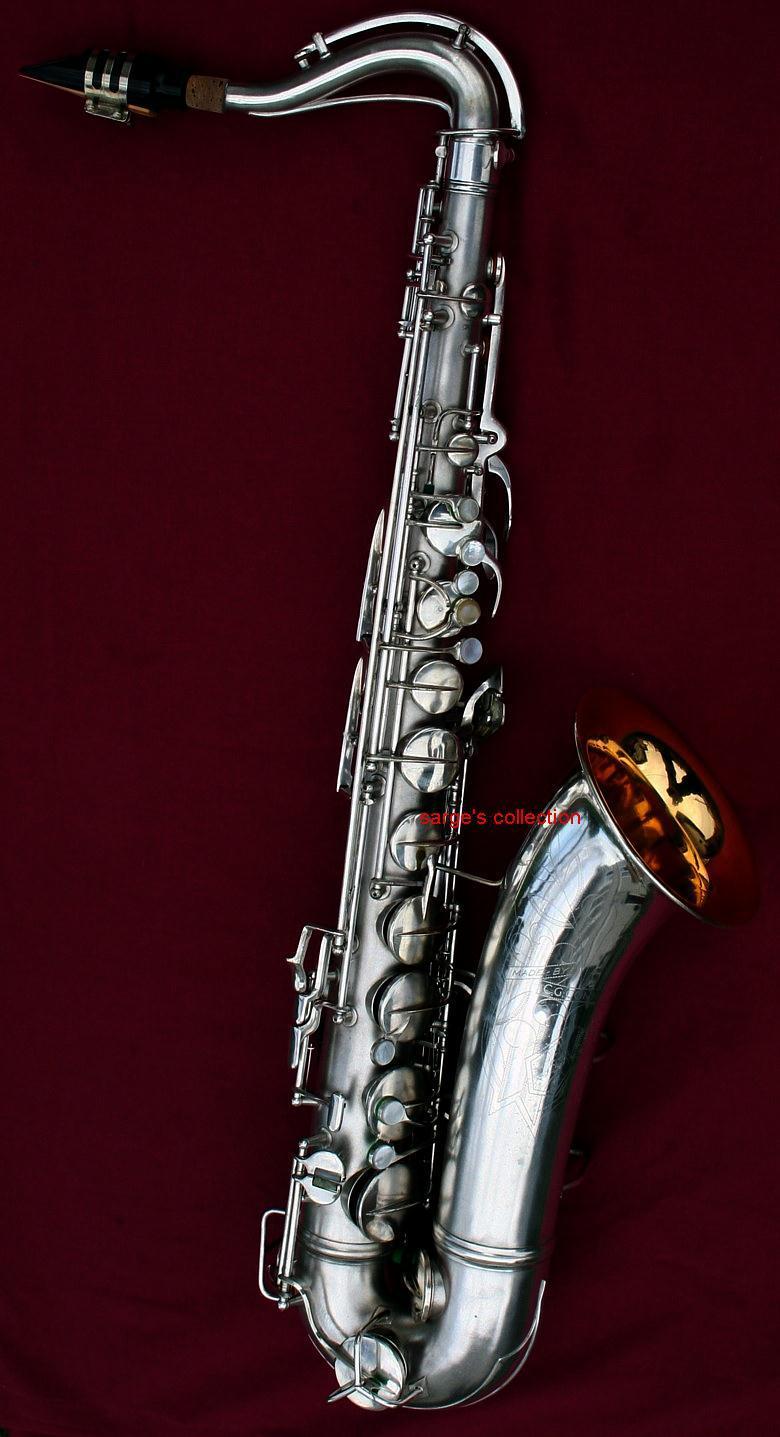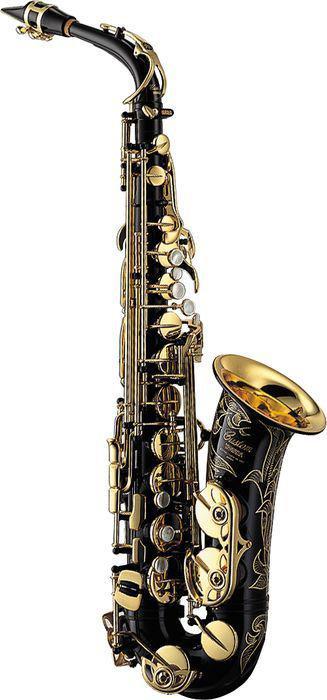The first image is the image on the left, the second image is the image on the right. Considering the images on both sides, is "Right image shows a saxophone with a decorative etching on the exterior of its bell end." valid? Answer yes or no. Yes. 